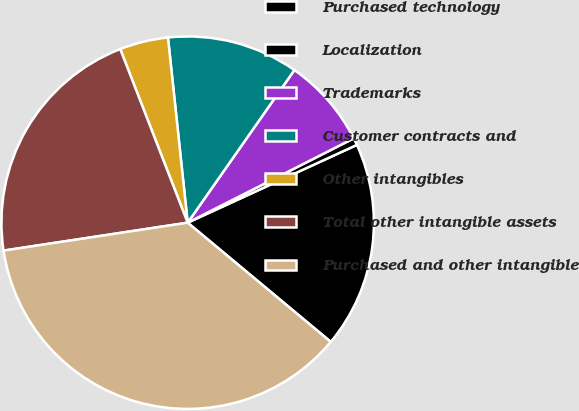Convert chart to OTSL. <chart><loc_0><loc_0><loc_500><loc_500><pie_chart><fcel>Purchased technology<fcel>Localization<fcel>Trademarks<fcel>Customer contracts and<fcel>Other intangibles<fcel>Total other intangible assets<fcel>Purchased and other intangible<nl><fcel>17.91%<fcel>0.62%<fcel>7.81%<fcel>11.4%<fcel>4.21%<fcel>21.5%<fcel>36.55%<nl></chart> 